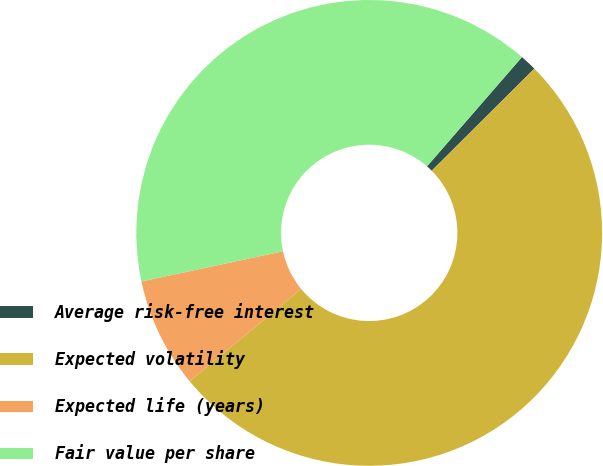<chart> <loc_0><loc_0><loc_500><loc_500><pie_chart><fcel>Average risk-free interest<fcel>Expected volatility<fcel>Expected life (years)<fcel>Fair value per share<nl><fcel>1.16%<fcel>51.47%<fcel>7.64%<fcel>39.73%<nl></chart> 